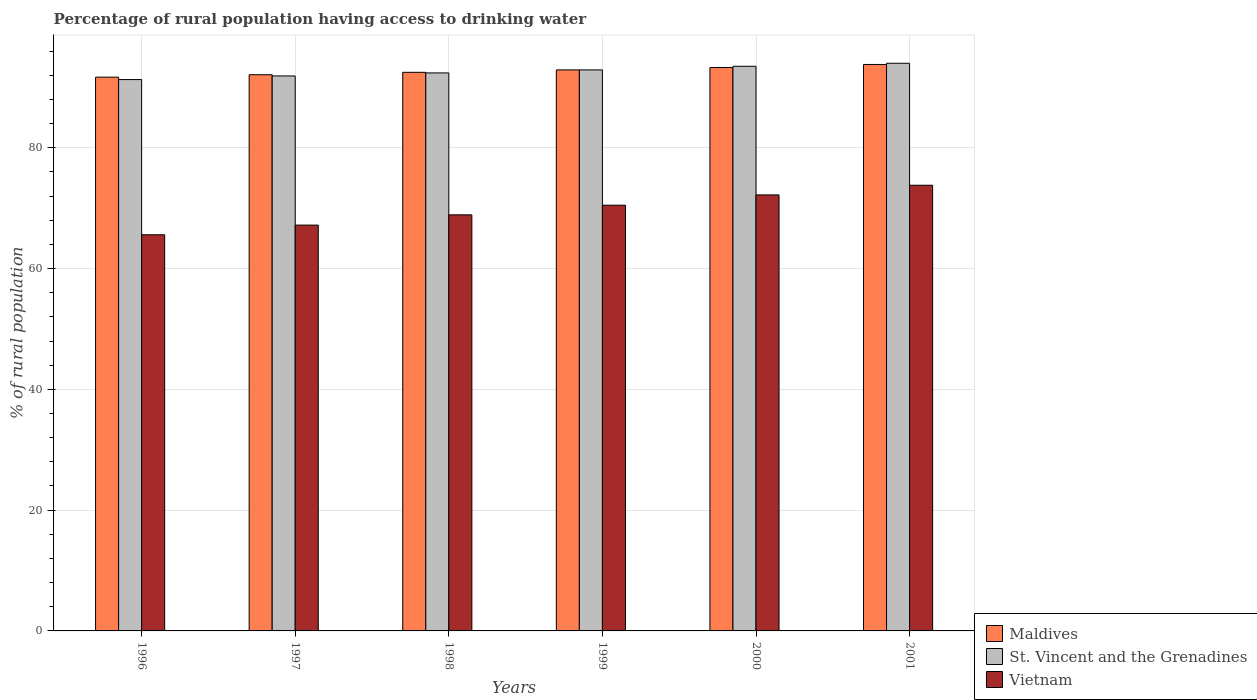How many different coloured bars are there?
Make the answer very short. 3. How many groups of bars are there?
Your response must be concise. 6. How many bars are there on the 4th tick from the right?
Ensure brevity in your answer.  3. In how many cases, is the number of bars for a given year not equal to the number of legend labels?
Offer a terse response. 0. What is the percentage of rural population having access to drinking water in Vietnam in 2001?
Provide a short and direct response. 73.8. Across all years, what is the maximum percentage of rural population having access to drinking water in Vietnam?
Keep it short and to the point. 73.8. Across all years, what is the minimum percentage of rural population having access to drinking water in St. Vincent and the Grenadines?
Your answer should be very brief. 91.3. What is the total percentage of rural population having access to drinking water in St. Vincent and the Grenadines in the graph?
Make the answer very short. 556. What is the difference between the percentage of rural population having access to drinking water in St. Vincent and the Grenadines in 1998 and that in 1999?
Offer a terse response. -0.5. What is the difference between the percentage of rural population having access to drinking water in Vietnam in 1998 and the percentage of rural population having access to drinking water in Maldives in 1999?
Offer a terse response. -24. What is the average percentage of rural population having access to drinking water in Maldives per year?
Your answer should be compact. 92.72. In the year 1998, what is the difference between the percentage of rural population having access to drinking water in Vietnam and percentage of rural population having access to drinking water in St. Vincent and the Grenadines?
Give a very brief answer. -23.5. In how many years, is the percentage of rural population having access to drinking water in St. Vincent and the Grenadines greater than 32 %?
Provide a succinct answer. 6. What is the ratio of the percentage of rural population having access to drinking water in St. Vincent and the Grenadines in 1997 to that in 1999?
Keep it short and to the point. 0.99. Is the difference between the percentage of rural population having access to drinking water in Vietnam in 2000 and 2001 greater than the difference between the percentage of rural population having access to drinking water in St. Vincent and the Grenadines in 2000 and 2001?
Your answer should be very brief. No. What is the difference between the highest and the second highest percentage of rural population having access to drinking water in Vietnam?
Provide a short and direct response. 1.6. What is the difference between the highest and the lowest percentage of rural population having access to drinking water in Maldives?
Your answer should be very brief. 2.1. In how many years, is the percentage of rural population having access to drinking water in Maldives greater than the average percentage of rural population having access to drinking water in Maldives taken over all years?
Your answer should be compact. 3. Is the sum of the percentage of rural population having access to drinking water in Vietnam in 1996 and 1998 greater than the maximum percentage of rural population having access to drinking water in Maldives across all years?
Your response must be concise. Yes. What does the 2nd bar from the left in 2001 represents?
Your response must be concise. St. Vincent and the Grenadines. What does the 3rd bar from the right in 1999 represents?
Ensure brevity in your answer.  Maldives. Is it the case that in every year, the sum of the percentage of rural population having access to drinking water in St. Vincent and the Grenadines and percentage of rural population having access to drinking water in Maldives is greater than the percentage of rural population having access to drinking water in Vietnam?
Give a very brief answer. Yes. How many bars are there?
Offer a very short reply. 18. How many years are there in the graph?
Your answer should be compact. 6. Are the values on the major ticks of Y-axis written in scientific E-notation?
Offer a terse response. No. Does the graph contain grids?
Your answer should be compact. Yes. Where does the legend appear in the graph?
Ensure brevity in your answer.  Bottom right. How many legend labels are there?
Your answer should be very brief. 3. What is the title of the graph?
Ensure brevity in your answer.  Percentage of rural population having access to drinking water. What is the label or title of the Y-axis?
Provide a succinct answer. % of rural population. What is the % of rural population in Maldives in 1996?
Your answer should be very brief. 91.7. What is the % of rural population in St. Vincent and the Grenadines in 1996?
Your answer should be compact. 91.3. What is the % of rural population of Vietnam in 1996?
Your answer should be compact. 65.6. What is the % of rural population in Maldives in 1997?
Your answer should be very brief. 92.1. What is the % of rural population of St. Vincent and the Grenadines in 1997?
Your response must be concise. 91.9. What is the % of rural population of Vietnam in 1997?
Ensure brevity in your answer.  67.2. What is the % of rural population in Maldives in 1998?
Make the answer very short. 92.5. What is the % of rural population in St. Vincent and the Grenadines in 1998?
Your answer should be compact. 92.4. What is the % of rural population in Vietnam in 1998?
Give a very brief answer. 68.9. What is the % of rural population in Maldives in 1999?
Provide a succinct answer. 92.9. What is the % of rural population of St. Vincent and the Grenadines in 1999?
Offer a very short reply. 92.9. What is the % of rural population in Vietnam in 1999?
Give a very brief answer. 70.5. What is the % of rural population in Maldives in 2000?
Provide a succinct answer. 93.3. What is the % of rural population in St. Vincent and the Grenadines in 2000?
Provide a short and direct response. 93.5. What is the % of rural population of Vietnam in 2000?
Your answer should be compact. 72.2. What is the % of rural population in Maldives in 2001?
Offer a very short reply. 93.8. What is the % of rural population in St. Vincent and the Grenadines in 2001?
Provide a short and direct response. 94. What is the % of rural population in Vietnam in 2001?
Provide a succinct answer. 73.8. Across all years, what is the maximum % of rural population in Maldives?
Provide a succinct answer. 93.8. Across all years, what is the maximum % of rural population of St. Vincent and the Grenadines?
Provide a short and direct response. 94. Across all years, what is the maximum % of rural population of Vietnam?
Keep it short and to the point. 73.8. Across all years, what is the minimum % of rural population in Maldives?
Ensure brevity in your answer.  91.7. Across all years, what is the minimum % of rural population of St. Vincent and the Grenadines?
Your response must be concise. 91.3. Across all years, what is the minimum % of rural population in Vietnam?
Your answer should be very brief. 65.6. What is the total % of rural population in Maldives in the graph?
Ensure brevity in your answer.  556.3. What is the total % of rural population in St. Vincent and the Grenadines in the graph?
Give a very brief answer. 556. What is the total % of rural population of Vietnam in the graph?
Offer a terse response. 418.2. What is the difference between the % of rural population of St. Vincent and the Grenadines in 1996 and that in 1997?
Your answer should be compact. -0.6. What is the difference between the % of rural population in Vietnam in 1996 and that in 1998?
Ensure brevity in your answer.  -3.3. What is the difference between the % of rural population in Maldives in 1996 and that in 1999?
Ensure brevity in your answer.  -1.2. What is the difference between the % of rural population of St. Vincent and the Grenadines in 1996 and that in 1999?
Keep it short and to the point. -1.6. What is the difference between the % of rural population of Vietnam in 1996 and that in 1999?
Keep it short and to the point. -4.9. What is the difference between the % of rural population of Vietnam in 1996 and that in 2000?
Ensure brevity in your answer.  -6.6. What is the difference between the % of rural population of Maldives in 1997 and that in 1998?
Give a very brief answer. -0.4. What is the difference between the % of rural population in St. Vincent and the Grenadines in 1997 and that in 1998?
Your answer should be compact. -0.5. What is the difference between the % of rural population in Vietnam in 1997 and that in 1998?
Keep it short and to the point. -1.7. What is the difference between the % of rural population of Maldives in 1997 and that in 1999?
Make the answer very short. -0.8. What is the difference between the % of rural population of St. Vincent and the Grenadines in 1997 and that in 2000?
Offer a very short reply. -1.6. What is the difference between the % of rural population in St. Vincent and the Grenadines in 1997 and that in 2001?
Give a very brief answer. -2.1. What is the difference between the % of rural population of St. Vincent and the Grenadines in 1998 and that in 1999?
Offer a terse response. -0.5. What is the difference between the % of rural population in Vietnam in 1998 and that in 1999?
Your answer should be compact. -1.6. What is the difference between the % of rural population in Maldives in 1998 and that in 2000?
Provide a succinct answer. -0.8. What is the difference between the % of rural population in Vietnam in 1998 and that in 2000?
Give a very brief answer. -3.3. What is the difference between the % of rural population of St. Vincent and the Grenadines in 1999 and that in 2000?
Offer a terse response. -0.6. What is the difference between the % of rural population in St. Vincent and the Grenadines in 1999 and that in 2001?
Offer a terse response. -1.1. What is the difference between the % of rural population of Vietnam in 2000 and that in 2001?
Provide a short and direct response. -1.6. What is the difference between the % of rural population in Maldives in 1996 and the % of rural population in Vietnam in 1997?
Provide a succinct answer. 24.5. What is the difference between the % of rural population of St. Vincent and the Grenadines in 1996 and the % of rural population of Vietnam in 1997?
Your answer should be compact. 24.1. What is the difference between the % of rural population in Maldives in 1996 and the % of rural population in St. Vincent and the Grenadines in 1998?
Your answer should be very brief. -0.7. What is the difference between the % of rural population in Maldives in 1996 and the % of rural population in Vietnam in 1998?
Provide a succinct answer. 22.8. What is the difference between the % of rural population in St. Vincent and the Grenadines in 1996 and the % of rural population in Vietnam in 1998?
Keep it short and to the point. 22.4. What is the difference between the % of rural population of Maldives in 1996 and the % of rural population of Vietnam in 1999?
Offer a very short reply. 21.2. What is the difference between the % of rural population in St. Vincent and the Grenadines in 1996 and the % of rural population in Vietnam in 1999?
Provide a short and direct response. 20.8. What is the difference between the % of rural population of Maldives in 1996 and the % of rural population of St. Vincent and the Grenadines in 2000?
Keep it short and to the point. -1.8. What is the difference between the % of rural population in Maldives in 1996 and the % of rural population in Vietnam in 2000?
Give a very brief answer. 19.5. What is the difference between the % of rural population of Maldives in 1996 and the % of rural population of Vietnam in 2001?
Your response must be concise. 17.9. What is the difference between the % of rural population in Maldives in 1997 and the % of rural population in Vietnam in 1998?
Offer a very short reply. 23.2. What is the difference between the % of rural population of St. Vincent and the Grenadines in 1997 and the % of rural population of Vietnam in 1998?
Keep it short and to the point. 23. What is the difference between the % of rural population in Maldives in 1997 and the % of rural population in Vietnam in 1999?
Your response must be concise. 21.6. What is the difference between the % of rural population in St. Vincent and the Grenadines in 1997 and the % of rural population in Vietnam in 1999?
Offer a very short reply. 21.4. What is the difference between the % of rural population in St. Vincent and the Grenadines in 1997 and the % of rural population in Vietnam in 2000?
Give a very brief answer. 19.7. What is the difference between the % of rural population in Maldives in 1997 and the % of rural population in St. Vincent and the Grenadines in 2001?
Your answer should be compact. -1.9. What is the difference between the % of rural population of St. Vincent and the Grenadines in 1997 and the % of rural population of Vietnam in 2001?
Keep it short and to the point. 18.1. What is the difference between the % of rural population in Maldives in 1998 and the % of rural population in St. Vincent and the Grenadines in 1999?
Offer a very short reply. -0.4. What is the difference between the % of rural population in Maldives in 1998 and the % of rural population in Vietnam in 1999?
Offer a very short reply. 22. What is the difference between the % of rural population in St. Vincent and the Grenadines in 1998 and the % of rural population in Vietnam in 1999?
Make the answer very short. 21.9. What is the difference between the % of rural population in Maldives in 1998 and the % of rural population in St. Vincent and the Grenadines in 2000?
Provide a short and direct response. -1. What is the difference between the % of rural population of Maldives in 1998 and the % of rural population of Vietnam in 2000?
Make the answer very short. 20.3. What is the difference between the % of rural population of St. Vincent and the Grenadines in 1998 and the % of rural population of Vietnam in 2000?
Offer a terse response. 20.2. What is the difference between the % of rural population in Maldives in 1998 and the % of rural population in Vietnam in 2001?
Provide a short and direct response. 18.7. What is the difference between the % of rural population in Maldives in 1999 and the % of rural population in St. Vincent and the Grenadines in 2000?
Ensure brevity in your answer.  -0.6. What is the difference between the % of rural population of Maldives in 1999 and the % of rural population of Vietnam in 2000?
Your answer should be very brief. 20.7. What is the difference between the % of rural population in St. Vincent and the Grenadines in 1999 and the % of rural population in Vietnam in 2000?
Provide a short and direct response. 20.7. What is the difference between the % of rural population in Maldives in 1999 and the % of rural population in St. Vincent and the Grenadines in 2001?
Keep it short and to the point. -1.1. What is the difference between the % of rural population in St. Vincent and the Grenadines in 1999 and the % of rural population in Vietnam in 2001?
Your answer should be very brief. 19.1. What is the difference between the % of rural population in Maldives in 2000 and the % of rural population in St. Vincent and the Grenadines in 2001?
Ensure brevity in your answer.  -0.7. What is the difference between the % of rural population in St. Vincent and the Grenadines in 2000 and the % of rural population in Vietnam in 2001?
Ensure brevity in your answer.  19.7. What is the average % of rural population of Maldives per year?
Offer a very short reply. 92.72. What is the average % of rural population of St. Vincent and the Grenadines per year?
Offer a terse response. 92.67. What is the average % of rural population in Vietnam per year?
Make the answer very short. 69.7. In the year 1996, what is the difference between the % of rural population in Maldives and % of rural population in St. Vincent and the Grenadines?
Offer a terse response. 0.4. In the year 1996, what is the difference between the % of rural population in Maldives and % of rural population in Vietnam?
Your answer should be compact. 26.1. In the year 1996, what is the difference between the % of rural population in St. Vincent and the Grenadines and % of rural population in Vietnam?
Ensure brevity in your answer.  25.7. In the year 1997, what is the difference between the % of rural population in Maldives and % of rural population in St. Vincent and the Grenadines?
Keep it short and to the point. 0.2. In the year 1997, what is the difference between the % of rural population of Maldives and % of rural population of Vietnam?
Provide a short and direct response. 24.9. In the year 1997, what is the difference between the % of rural population of St. Vincent and the Grenadines and % of rural population of Vietnam?
Ensure brevity in your answer.  24.7. In the year 1998, what is the difference between the % of rural population in Maldives and % of rural population in St. Vincent and the Grenadines?
Your answer should be very brief. 0.1. In the year 1998, what is the difference between the % of rural population of Maldives and % of rural population of Vietnam?
Your answer should be compact. 23.6. In the year 1999, what is the difference between the % of rural population of Maldives and % of rural population of Vietnam?
Provide a short and direct response. 22.4. In the year 1999, what is the difference between the % of rural population of St. Vincent and the Grenadines and % of rural population of Vietnam?
Your answer should be compact. 22.4. In the year 2000, what is the difference between the % of rural population of Maldives and % of rural population of St. Vincent and the Grenadines?
Your answer should be compact. -0.2. In the year 2000, what is the difference between the % of rural population in Maldives and % of rural population in Vietnam?
Give a very brief answer. 21.1. In the year 2000, what is the difference between the % of rural population of St. Vincent and the Grenadines and % of rural population of Vietnam?
Ensure brevity in your answer.  21.3. In the year 2001, what is the difference between the % of rural population of Maldives and % of rural population of Vietnam?
Your response must be concise. 20. In the year 2001, what is the difference between the % of rural population of St. Vincent and the Grenadines and % of rural population of Vietnam?
Your answer should be very brief. 20.2. What is the ratio of the % of rural population of Vietnam in 1996 to that in 1997?
Give a very brief answer. 0.98. What is the ratio of the % of rural population in St. Vincent and the Grenadines in 1996 to that in 1998?
Provide a succinct answer. 0.99. What is the ratio of the % of rural population in Vietnam in 1996 to that in 1998?
Your answer should be very brief. 0.95. What is the ratio of the % of rural population of Maldives in 1996 to that in 1999?
Provide a succinct answer. 0.99. What is the ratio of the % of rural population in St. Vincent and the Grenadines in 1996 to that in 1999?
Ensure brevity in your answer.  0.98. What is the ratio of the % of rural population of Vietnam in 1996 to that in 1999?
Your answer should be very brief. 0.93. What is the ratio of the % of rural population in Maldives in 1996 to that in 2000?
Keep it short and to the point. 0.98. What is the ratio of the % of rural population of St. Vincent and the Grenadines in 1996 to that in 2000?
Keep it short and to the point. 0.98. What is the ratio of the % of rural population in Vietnam in 1996 to that in 2000?
Ensure brevity in your answer.  0.91. What is the ratio of the % of rural population of Maldives in 1996 to that in 2001?
Your response must be concise. 0.98. What is the ratio of the % of rural population in St. Vincent and the Grenadines in 1996 to that in 2001?
Provide a succinct answer. 0.97. What is the ratio of the % of rural population in Vietnam in 1996 to that in 2001?
Give a very brief answer. 0.89. What is the ratio of the % of rural population of Maldives in 1997 to that in 1998?
Ensure brevity in your answer.  1. What is the ratio of the % of rural population of St. Vincent and the Grenadines in 1997 to that in 1998?
Your response must be concise. 0.99. What is the ratio of the % of rural population in Vietnam in 1997 to that in 1998?
Offer a terse response. 0.98. What is the ratio of the % of rural population of St. Vincent and the Grenadines in 1997 to that in 1999?
Offer a very short reply. 0.99. What is the ratio of the % of rural population of Vietnam in 1997 to that in 1999?
Provide a short and direct response. 0.95. What is the ratio of the % of rural population of Maldives in 1997 to that in 2000?
Ensure brevity in your answer.  0.99. What is the ratio of the % of rural population of St. Vincent and the Grenadines in 1997 to that in 2000?
Ensure brevity in your answer.  0.98. What is the ratio of the % of rural population of Vietnam in 1997 to that in 2000?
Your answer should be very brief. 0.93. What is the ratio of the % of rural population of Maldives in 1997 to that in 2001?
Your answer should be compact. 0.98. What is the ratio of the % of rural population of St. Vincent and the Grenadines in 1997 to that in 2001?
Your answer should be very brief. 0.98. What is the ratio of the % of rural population in Vietnam in 1997 to that in 2001?
Keep it short and to the point. 0.91. What is the ratio of the % of rural population in Vietnam in 1998 to that in 1999?
Provide a succinct answer. 0.98. What is the ratio of the % of rural population of Vietnam in 1998 to that in 2000?
Provide a short and direct response. 0.95. What is the ratio of the % of rural population in Maldives in 1998 to that in 2001?
Keep it short and to the point. 0.99. What is the ratio of the % of rural population of Vietnam in 1998 to that in 2001?
Your answer should be very brief. 0.93. What is the ratio of the % of rural population in Vietnam in 1999 to that in 2000?
Offer a terse response. 0.98. What is the ratio of the % of rural population in St. Vincent and the Grenadines in 1999 to that in 2001?
Your response must be concise. 0.99. What is the ratio of the % of rural population in Vietnam in 1999 to that in 2001?
Offer a very short reply. 0.96. What is the ratio of the % of rural population in Vietnam in 2000 to that in 2001?
Provide a short and direct response. 0.98. What is the difference between the highest and the second highest % of rural population of St. Vincent and the Grenadines?
Your answer should be compact. 0.5. What is the difference between the highest and the second highest % of rural population of Vietnam?
Keep it short and to the point. 1.6. What is the difference between the highest and the lowest % of rural population in St. Vincent and the Grenadines?
Ensure brevity in your answer.  2.7. 